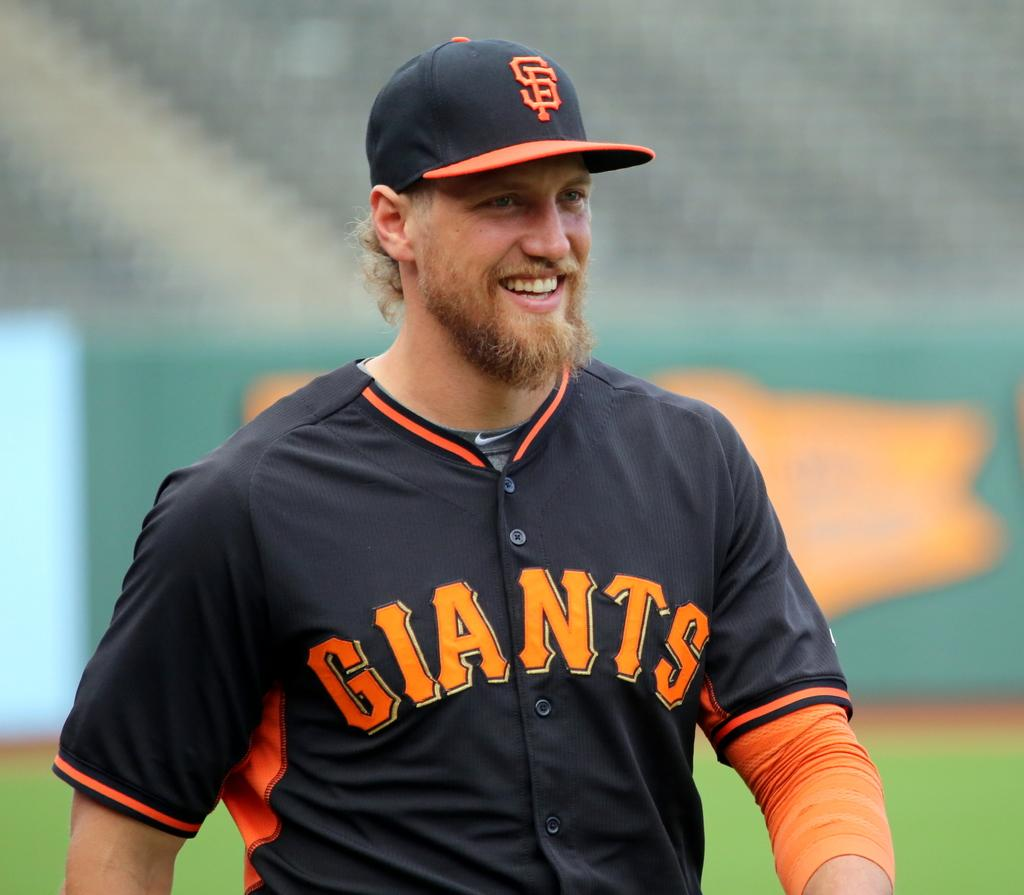Provide a one-sentence caption for the provided image. A baseball played with a giants jersey is smiling. 